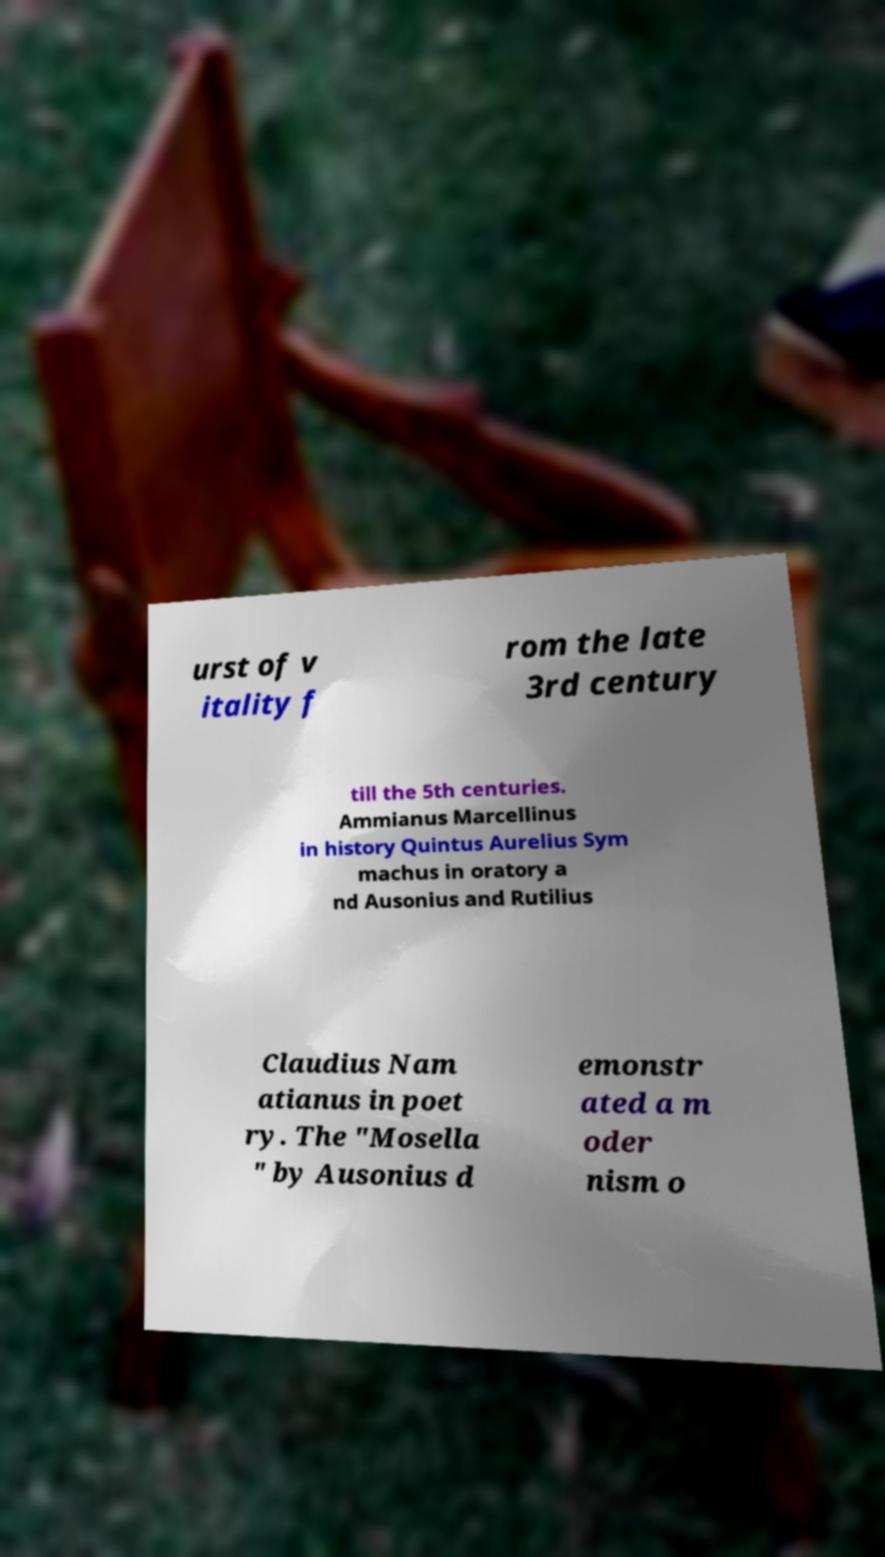I need the written content from this picture converted into text. Can you do that? urst of v itality f rom the late 3rd century till the 5th centuries. Ammianus Marcellinus in history Quintus Aurelius Sym machus in oratory a nd Ausonius and Rutilius Claudius Nam atianus in poet ry. The "Mosella " by Ausonius d emonstr ated a m oder nism o 